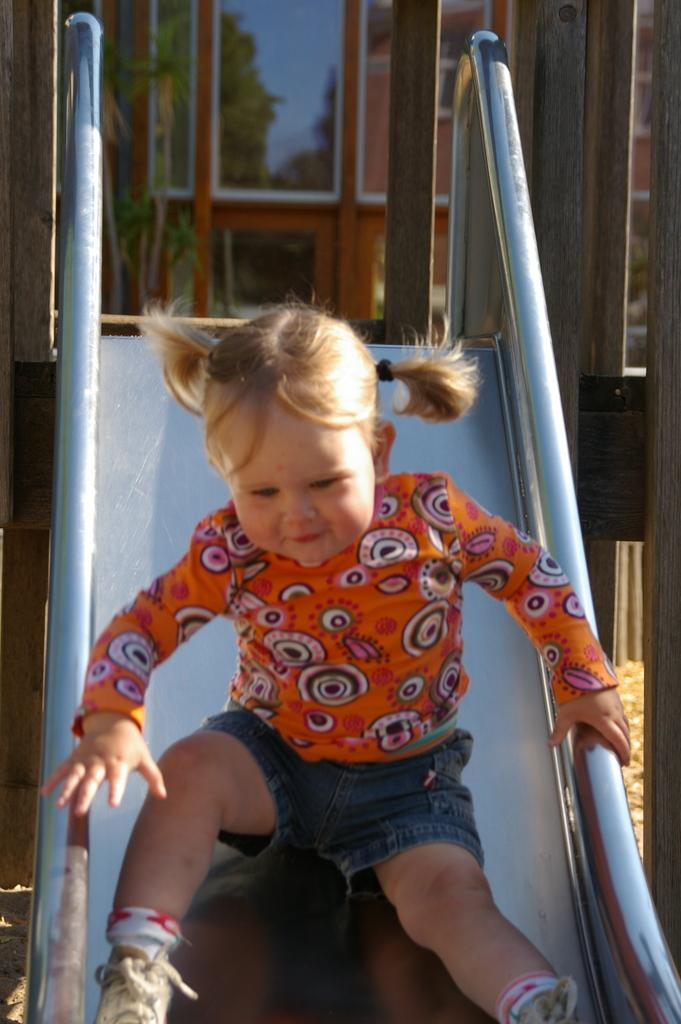What is the main subject of the image? The main subject of the image is a girl child. Where is the girl child located in the image? The girl child is on playground equipment. What can be seen in the background of the image? There is a door with a glass panel visible in the background of the image. What is the girl child's opinion on breakfast in the image? There is no information about the girl child's opinion on breakfast in the image. 